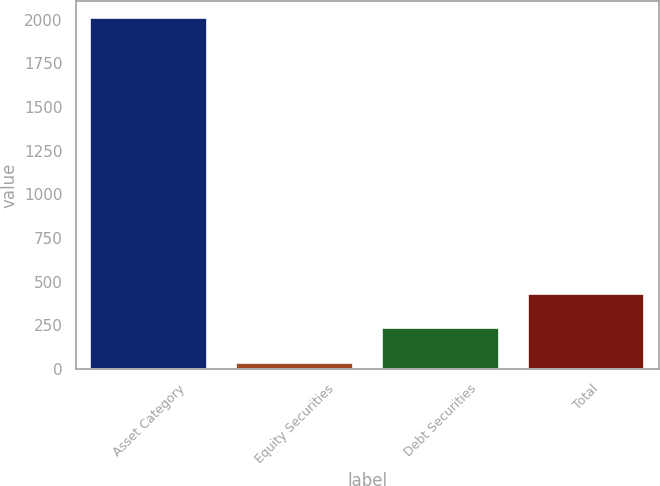Convert chart to OTSL. <chart><loc_0><loc_0><loc_500><loc_500><bar_chart><fcel>Asset Category<fcel>Equity Securities<fcel>Debt Securities<fcel>Total<nl><fcel>2007<fcel>37<fcel>234<fcel>431<nl></chart> 